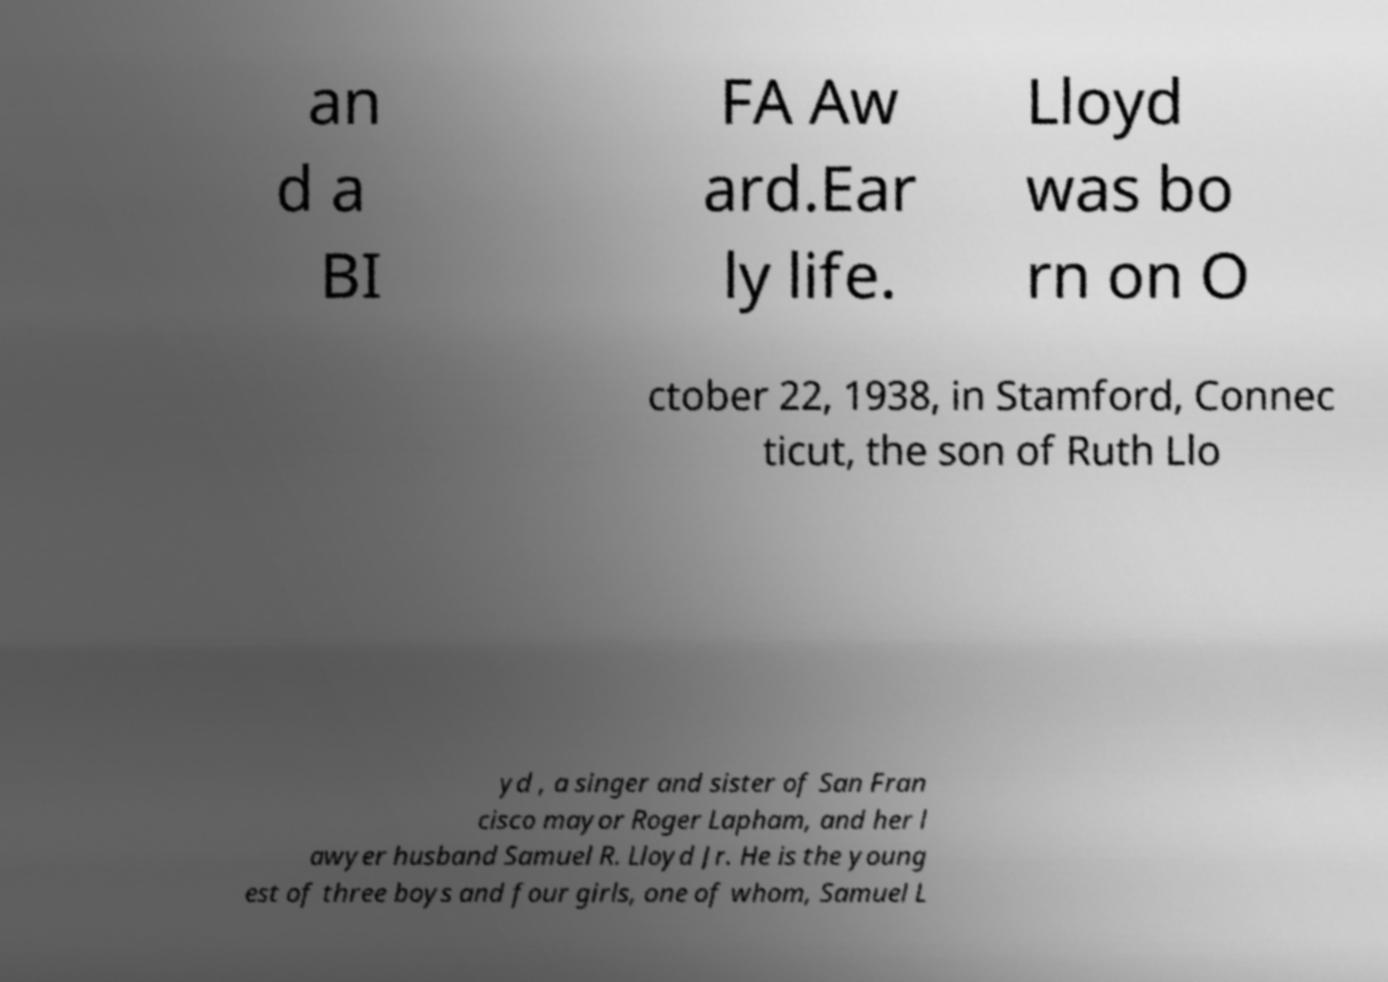Can you accurately transcribe the text from the provided image for me? an d a BI FA Aw ard.Ear ly life. Lloyd was bo rn on O ctober 22, 1938, in Stamford, Connec ticut, the son of Ruth Llo yd , a singer and sister of San Fran cisco mayor Roger Lapham, and her l awyer husband Samuel R. Lloyd Jr. He is the young est of three boys and four girls, one of whom, Samuel L 